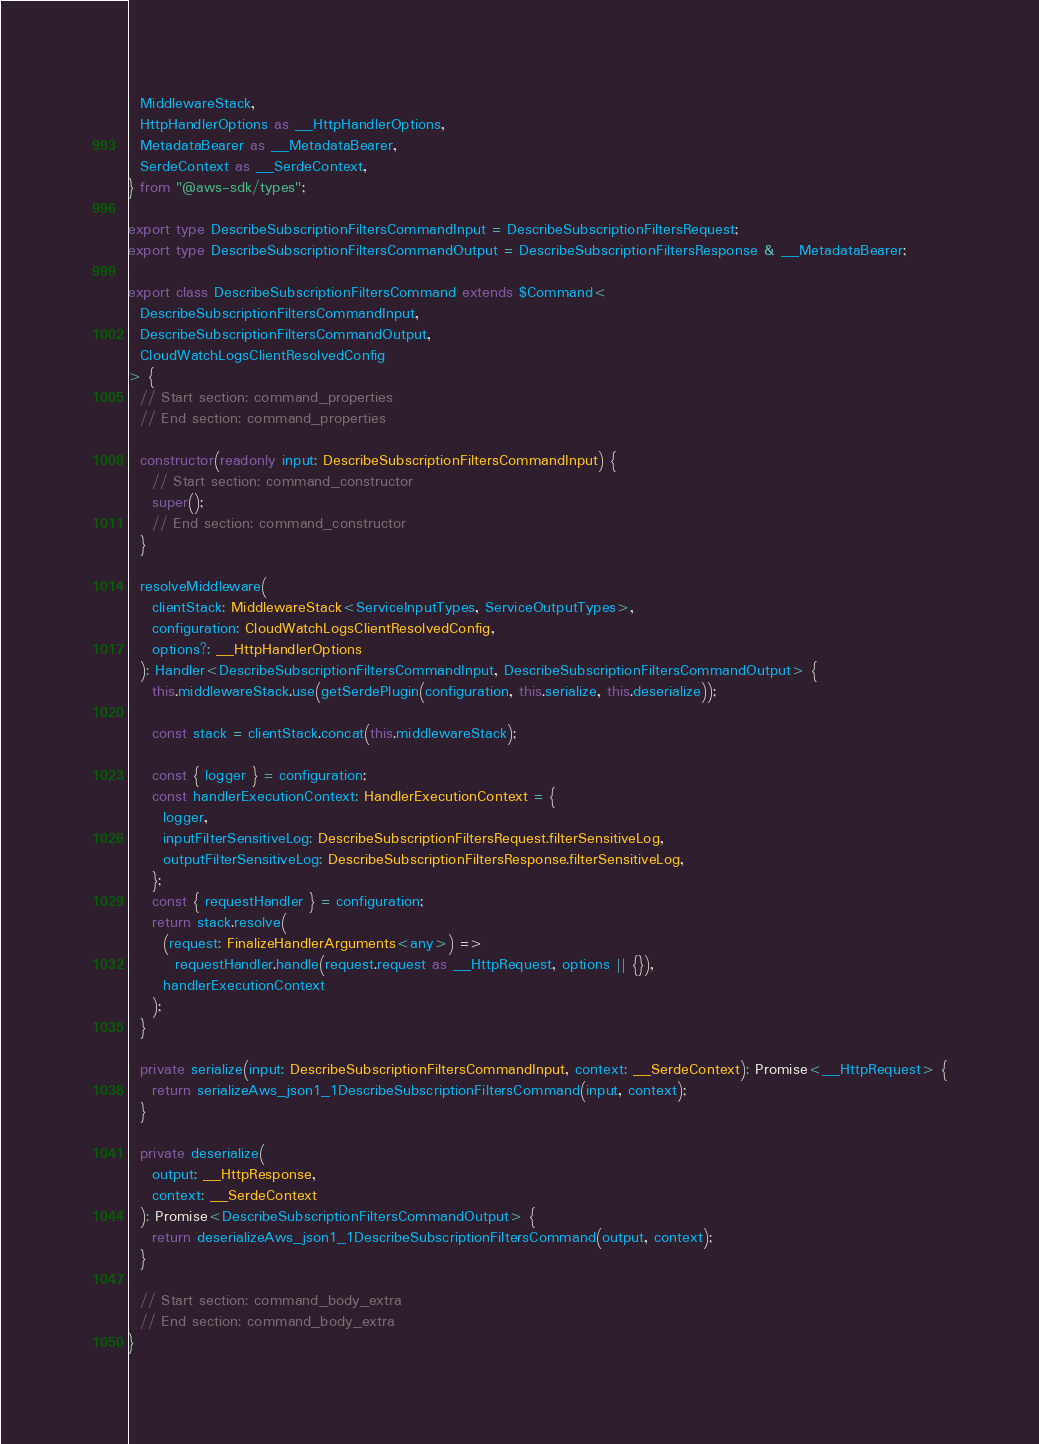Convert code to text. <code><loc_0><loc_0><loc_500><loc_500><_TypeScript_>  MiddlewareStack,
  HttpHandlerOptions as __HttpHandlerOptions,
  MetadataBearer as __MetadataBearer,
  SerdeContext as __SerdeContext,
} from "@aws-sdk/types";

export type DescribeSubscriptionFiltersCommandInput = DescribeSubscriptionFiltersRequest;
export type DescribeSubscriptionFiltersCommandOutput = DescribeSubscriptionFiltersResponse & __MetadataBearer;

export class DescribeSubscriptionFiltersCommand extends $Command<
  DescribeSubscriptionFiltersCommandInput,
  DescribeSubscriptionFiltersCommandOutput,
  CloudWatchLogsClientResolvedConfig
> {
  // Start section: command_properties
  // End section: command_properties

  constructor(readonly input: DescribeSubscriptionFiltersCommandInput) {
    // Start section: command_constructor
    super();
    // End section: command_constructor
  }

  resolveMiddleware(
    clientStack: MiddlewareStack<ServiceInputTypes, ServiceOutputTypes>,
    configuration: CloudWatchLogsClientResolvedConfig,
    options?: __HttpHandlerOptions
  ): Handler<DescribeSubscriptionFiltersCommandInput, DescribeSubscriptionFiltersCommandOutput> {
    this.middlewareStack.use(getSerdePlugin(configuration, this.serialize, this.deserialize));

    const stack = clientStack.concat(this.middlewareStack);

    const { logger } = configuration;
    const handlerExecutionContext: HandlerExecutionContext = {
      logger,
      inputFilterSensitiveLog: DescribeSubscriptionFiltersRequest.filterSensitiveLog,
      outputFilterSensitiveLog: DescribeSubscriptionFiltersResponse.filterSensitiveLog,
    };
    const { requestHandler } = configuration;
    return stack.resolve(
      (request: FinalizeHandlerArguments<any>) =>
        requestHandler.handle(request.request as __HttpRequest, options || {}),
      handlerExecutionContext
    );
  }

  private serialize(input: DescribeSubscriptionFiltersCommandInput, context: __SerdeContext): Promise<__HttpRequest> {
    return serializeAws_json1_1DescribeSubscriptionFiltersCommand(input, context);
  }

  private deserialize(
    output: __HttpResponse,
    context: __SerdeContext
  ): Promise<DescribeSubscriptionFiltersCommandOutput> {
    return deserializeAws_json1_1DescribeSubscriptionFiltersCommand(output, context);
  }

  // Start section: command_body_extra
  // End section: command_body_extra
}
</code> 